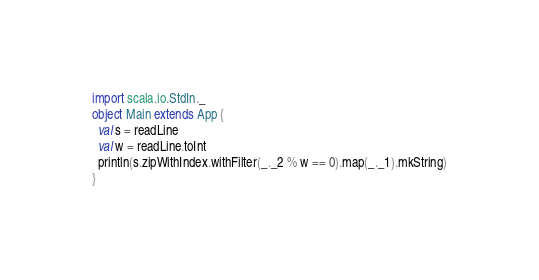<code> <loc_0><loc_0><loc_500><loc_500><_Scala_>import scala.io.StdIn._
object Main extends App {
  val s = readLine
  val w = readLine.toInt
  println(s.zipWithIndex.withFilter(_._2 % w == 0).map(_._1).mkString)
}</code> 